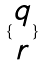<formula> <loc_0><loc_0><loc_500><loc_500>\{ \begin{matrix} q \\ r \end{matrix} \}</formula> 